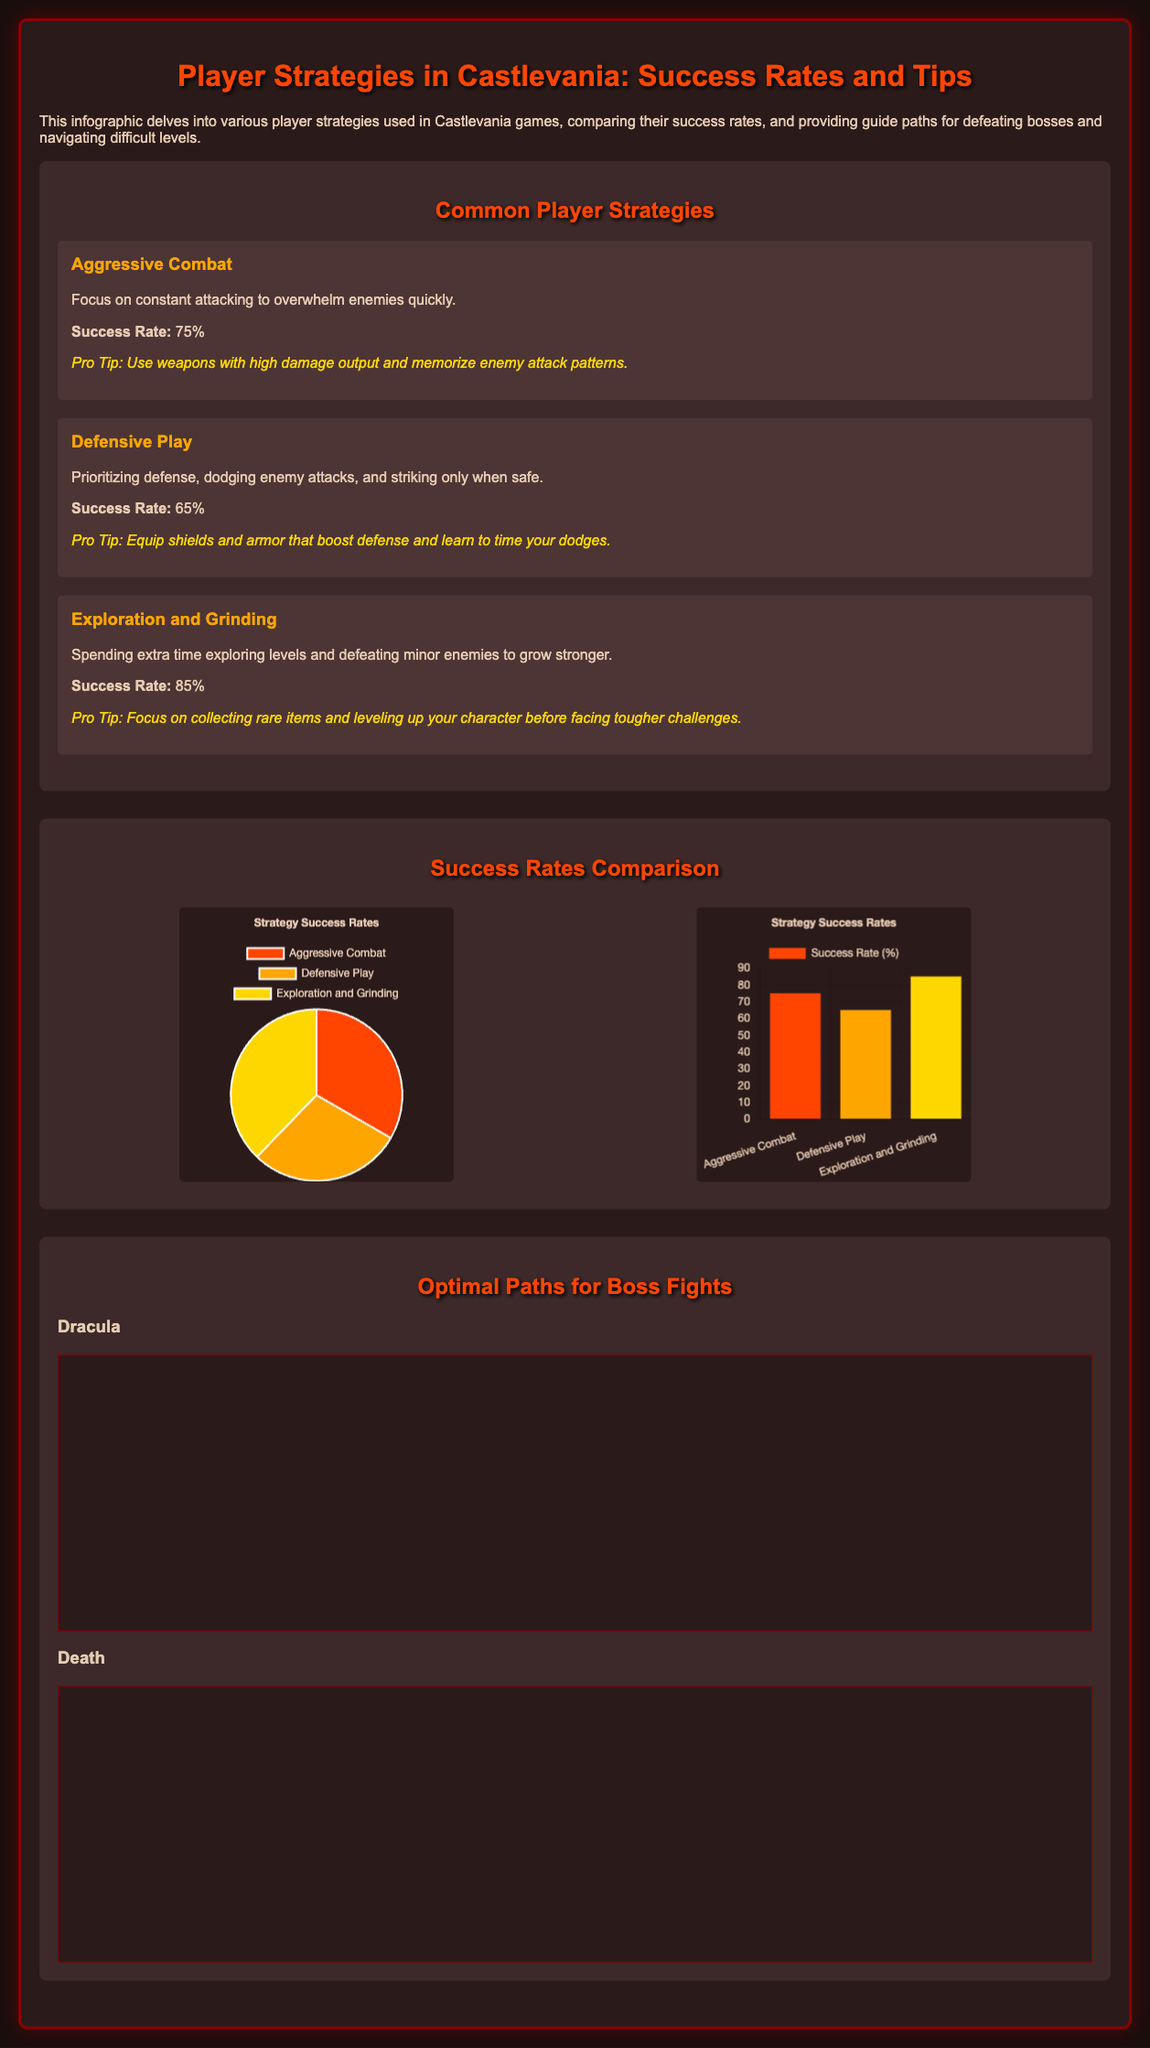What is the success rate of Aggressive Combat? The success rate of Aggressive Combat is explicitly stated in the document.
Answer: 75% What weapon is suggested for the fight against Dracula? The document mentions equipping Holy Water as a strategy against Dracula.
Answer: Holy Water What is the success rate of Defensive Play? The success rate of Defensive Play is provided directly in the section about Common Player Strategies.
Answer: 65% Which strategy has the highest success rate? The success rates for each strategy allow for a straightforward comparison, revealing the top strategy.
Answer: Exploration and Grinding What color represents Exploration and Grinding in the pie chart? The document notes the color associated with each strategy in the pie chart.
Answer: Yellow How many steps are there in the flowchart for defeating Death? The flowchart for defeating Death comprises multiple steps, which can be counted directly from the nodes.
Answer: 5 What is the main focus of Defensive Play? The description for Defensive Play summarizes its core focus.
Answer: Dodging enemy attacks What is the pro tip for Exploration and Grinding? The pro tip for Exploration and Grinding is listed in the respective strategy section.
Answer: Collect rare items and level up What color corresponds to the Successful outcome in the flowchart? The flowchart shows different colors for various outcomes, indicating success explicitly.
Answer: Green 